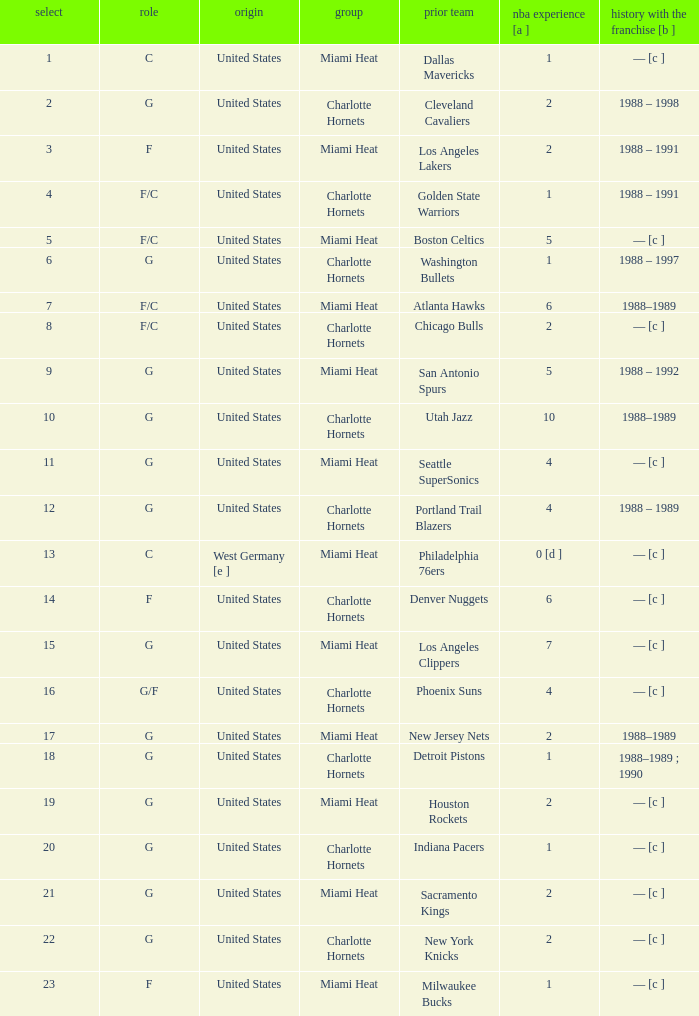Write the full table. {'header': ['select', 'role', 'origin', 'group', 'prior team', 'nba experience [a ]', 'history with the franchise [b ]'], 'rows': [['1', 'C', 'United States', 'Miami Heat', 'Dallas Mavericks', '1', '— [c ]'], ['2', 'G', 'United States', 'Charlotte Hornets', 'Cleveland Cavaliers', '2', '1988 – 1998'], ['3', 'F', 'United States', 'Miami Heat', 'Los Angeles Lakers', '2', '1988 – 1991'], ['4', 'F/C', 'United States', 'Charlotte Hornets', 'Golden State Warriors', '1', '1988 – 1991'], ['5', 'F/C', 'United States', 'Miami Heat', 'Boston Celtics', '5', '— [c ]'], ['6', 'G', 'United States', 'Charlotte Hornets', 'Washington Bullets', '1', '1988 – 1997'], ['7', 'F/C', 'United States', 'Miami Heat', 'Atlanta Hawks', '6', '1988–1989'], ['8', 'F/C', 'United States', 'Charlotte Hornets', 'Chicago Bulls', '2', '— [c ]'], ['9', 'G', 'United States', 'Miami Heat', 'San Antonio Spurs', '5', '1988 – 1992'], ['10', 'G', 'United States', 'Charlotte Hornets', 'Utah Jazz', '10', '1988–1989'], ['11', 'G', 'United States', 'Miami Heat', 'Seattle SuperSonics', '4', '— [c ]'], ['12', 'G', 'United States', 'Charlotte Hornets', 'Portland Trail Blazers', '4', '1988 – 1989'], ['13', 'C', 'West Germany [e ]', 'Miami Heat', 'Philadelphia 76ers', '0 [d ]', '— [c ]'], ['14', 'F', 'United States', 'Charlotte Hornets', 'Denver Nuggets', '6', '— [c ]'], ['15', 'G', 'United States', 'Miami Heat', 'Los Angeles Clippers', '7', '— [c ]'], ['16', 'G/F', 'United States', 'Charlotte Hornets', 'Phoenix Suns', '4', '— [c ]'], ['17', 'G', 'United States', 'Miami Heat', 'New Jersey Nets', '2', '1988–1989'], ['18', 'G', 'United States', 'Charlotte Hornets', 'Detroit Pistons', '1', '1988–1989 ; 1990'], ['19', 'G', 'United States', 'Miami Heat', 'Houston Rockets', '2', '— [c ]'], ['20', 'G', 'United States', 'Charlotte Hornets', 'Indiana Pacers', '1', '— [c ]'], ['21', 'G', 'United States', 'Miami Heat', 'Sacramento Kings', '2', '— [c ]'], ['22', 'G', 'United States', 'Charlotte Hornets', 'New York Knicks', '2', '— [c ]'], ['23', 'F', 'United States', 'Miami Heat', 'Milwaukee Bucks', '1', '— [c ]']]} What is the previous team of the player with 4 NBA years and a pick less than 16? Seattle SuperSonics, Portland Trail Blazers. 